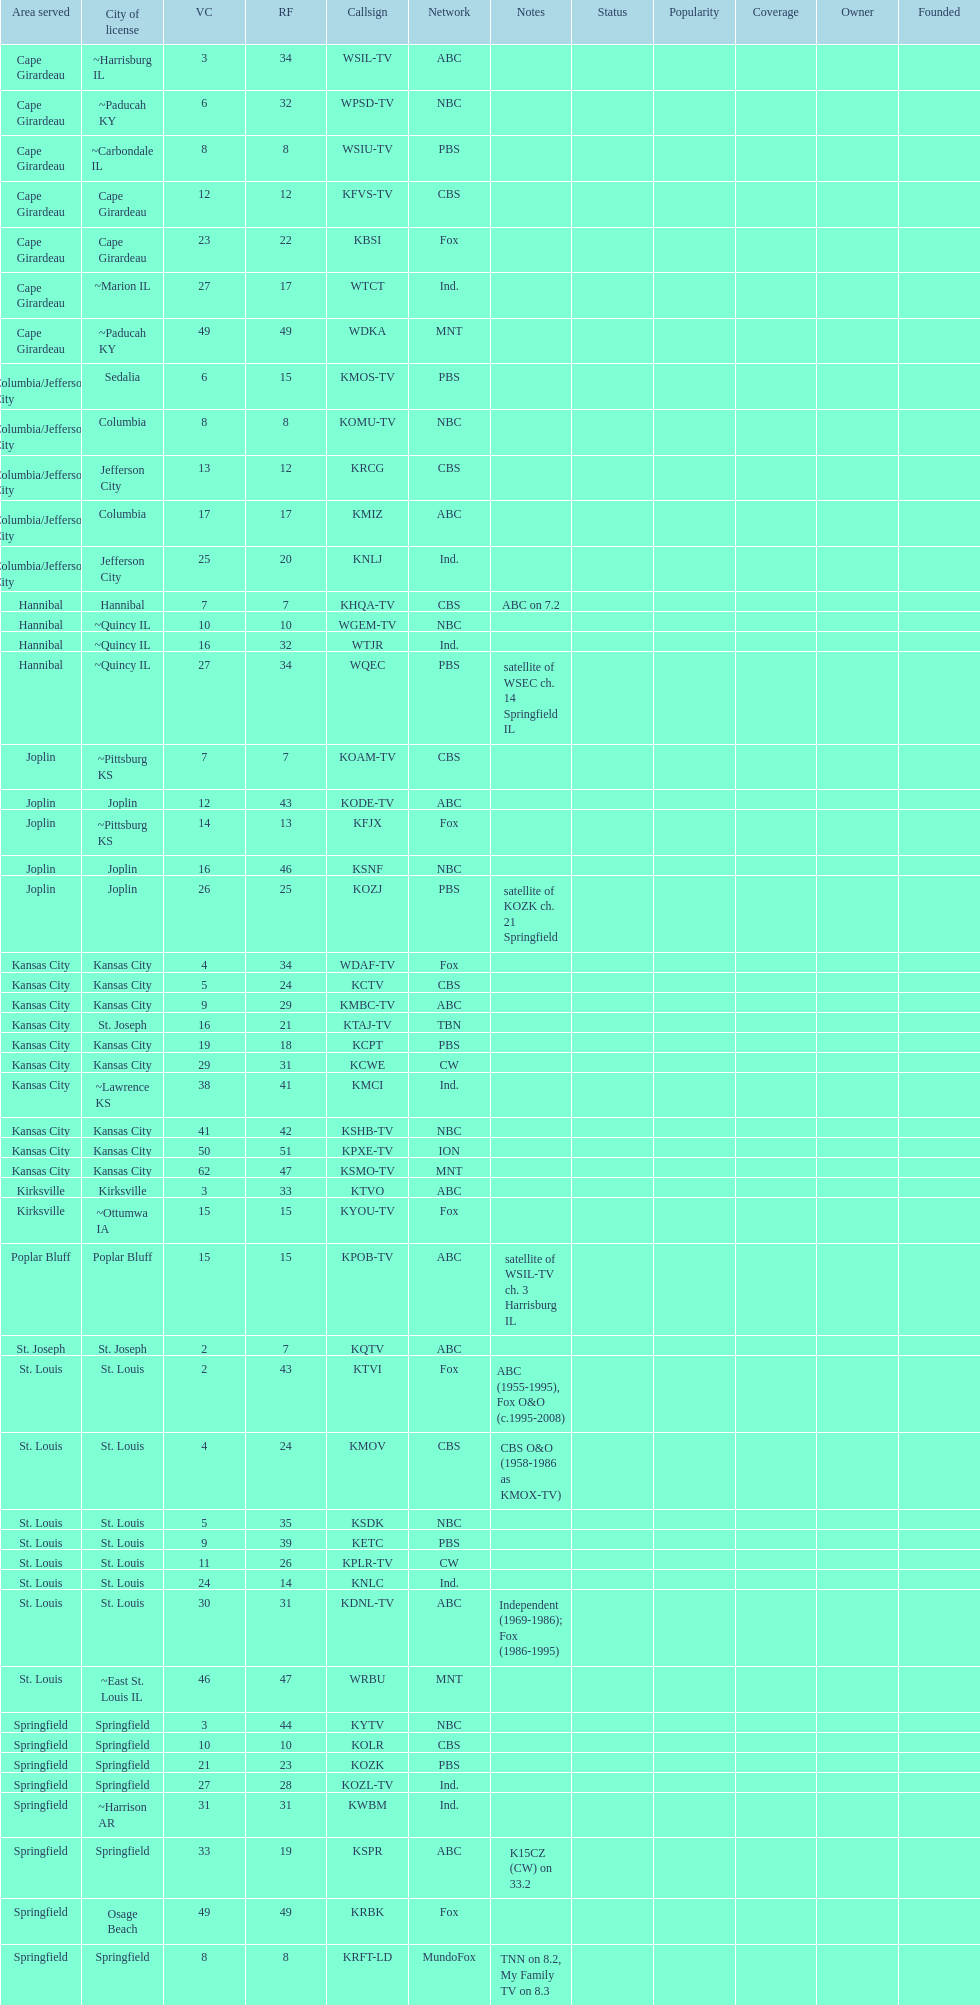How many of these missouri tv stations are actually licensed in a city in illinois (il)? 7. 